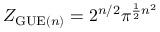Convert formula to latex. <formula><loc_0><loc_0><loc_500><loc_500>Z _ { { G U E } ( n ) } = 2 ^ { n / 2 } \pi ^ { { \frac { 1 } { 2 } } n ^ { 2 } }</formula> 